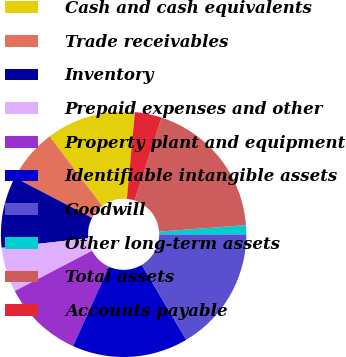Convert chart to OTSL. <chart><loc_0><loc_0><loc_500><loc_500><pie_chart><fcel>Cash and cash equivalents<fcel>Trade receivables<fcel>Inventory<fcel>Prepaid expenses and other<fcel>Property plant and equipment<fcel>Identifiable intangible assets<fcel>Goodwill<fcel>Other long-term assets<fcel>Total assets<fcel>Accounts payable<nl><fcel>11.76%<fcel>7.06%<fcel>9.41%<fcel>5.89%<fcel>10.59%<fcel>15.29%<fcel>16.46%<fcel>1.19%<fcel>18.81%<fcel>3.54%<nl></chart> 